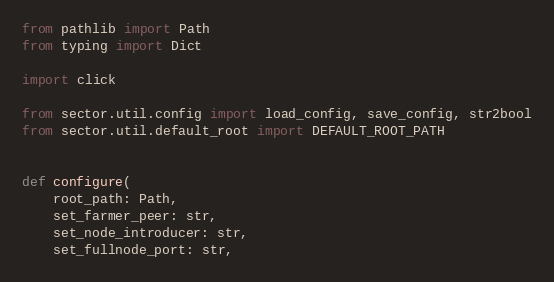<code> <loc_0><loc_0><loc_500><loc_500><_Python_>from pathlib import Path
from typing import Dict

import click

from sector.util.config import load_config, save_config, str2bool
from sector.util.default_root import DEFAULT_ROOT_PATH


def configure(
    root_path: Path,
    set_farmer_peer: str,
    set_node_introducer: str,
    set_fullnode_port: str,</code> 